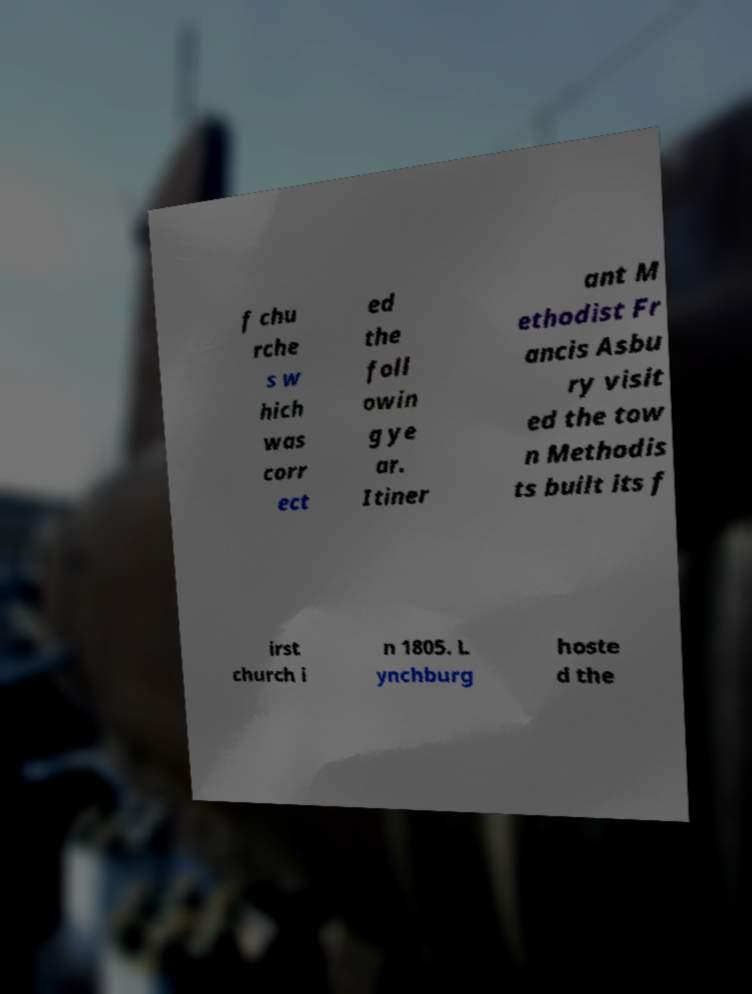Please read and relay the text visible in this image. What does it say? f chu rche s w hich was corr ect ed the foll owin g ye ar. Itiner ant M ethodist Fr ancis Asbu ry visit ed the tow n Methodis ts built its f irst church i n 1805. L ynchburg hoste d the 